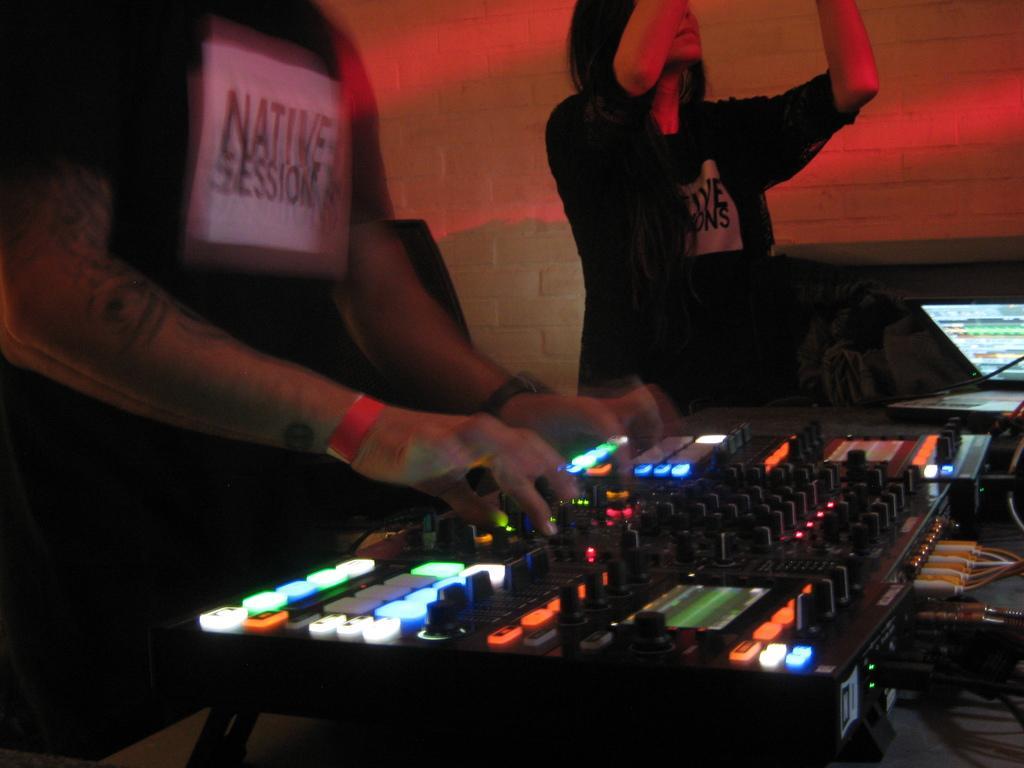Can you describe this image briefly? In this image, on the right there is a woman. On the left there is a person. In the middle there are controlling machines, lights, buttons, cables, a laptop, some other objects. In the background there is a wall. 